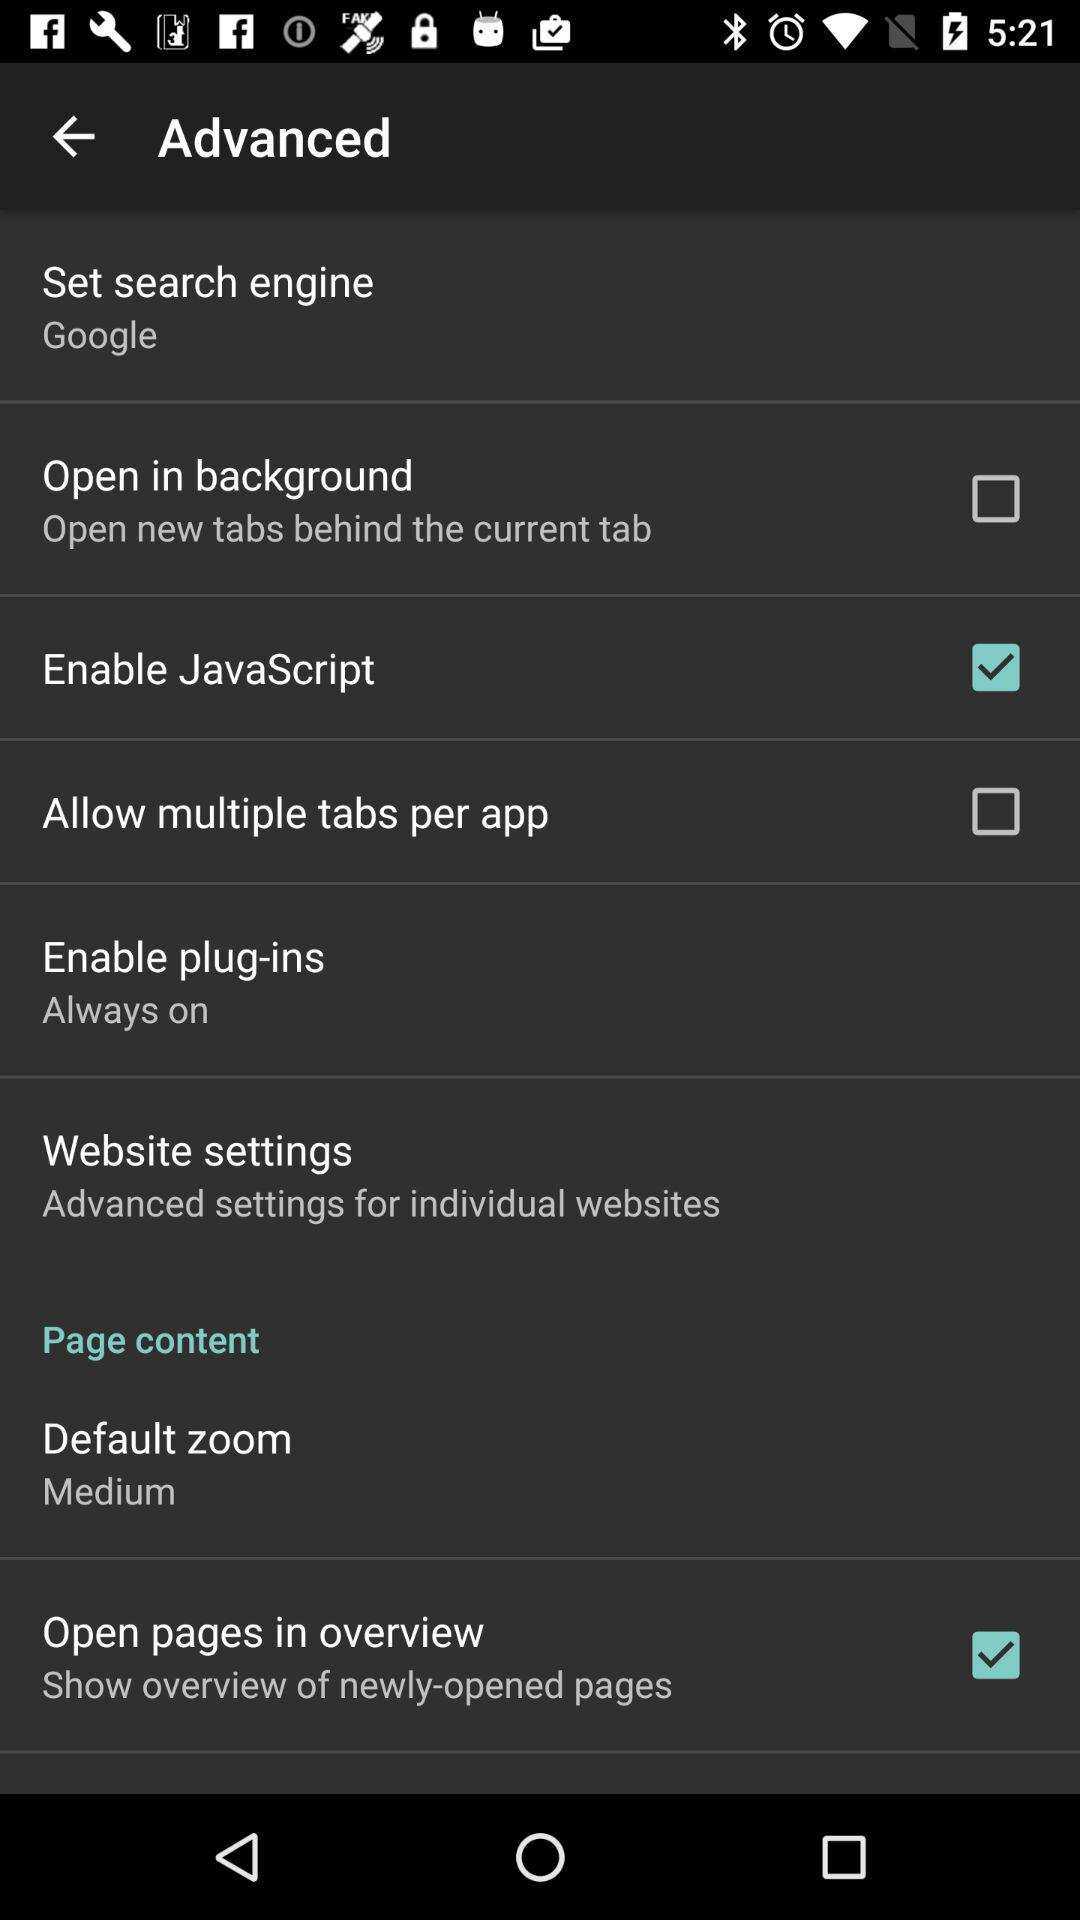Which option is checked? The checked option is "Enable JavaScript" and "Open pages in overview". 